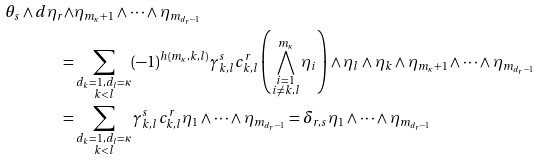Convert formula to latex. <formula><loc_0><loc_0><loc_500><loc_500>\theta _ { s } \wedge d \eta _ { r } \wedge & \eta _ { m _ { \kappa } + 1 } \wedge \dots \wedge \eta _ { m _ { d _ { r } - 1 } } \\ = & \sum _ { \substack { d _ { k } = 1 , d _ { l } = \kappa \\ k < l } } ( - 1 ) ^ { h ( m _ { \kappa } , k , l ) } \gamma ^ { s } _ { k , l } c _ { k , l } ^ { r } \left ( \bigwedge _ { \substack { i = 1 \\ i \neq k , l } } ^ { m _ { \kappa } } \eta _ { i } \right ) \wedge \eta _ { l } \wedge \eta _ { k } \wedge \eta _ { m _ { \kappa } + 1 } \wedge \dots \wedge \eta _ { m _ { d _ { r } - 1 } } \\ = & \sum _ { \substack { d _ { k } = 1 , d _ { l } = \kappa \\ k < l } } \gamma ^ { s } _ { k , l } c _ { k , l } ^ { r } \eta _ { 1 } \wedge \dots \wedge \eta _ { m _ { d _ { r } - 1 } } = \delta _ { r , s } \eta _ { 1 } \wedge \dots \wedge \eta _ { m _ { d _ { r } - 1 } }</formula> 